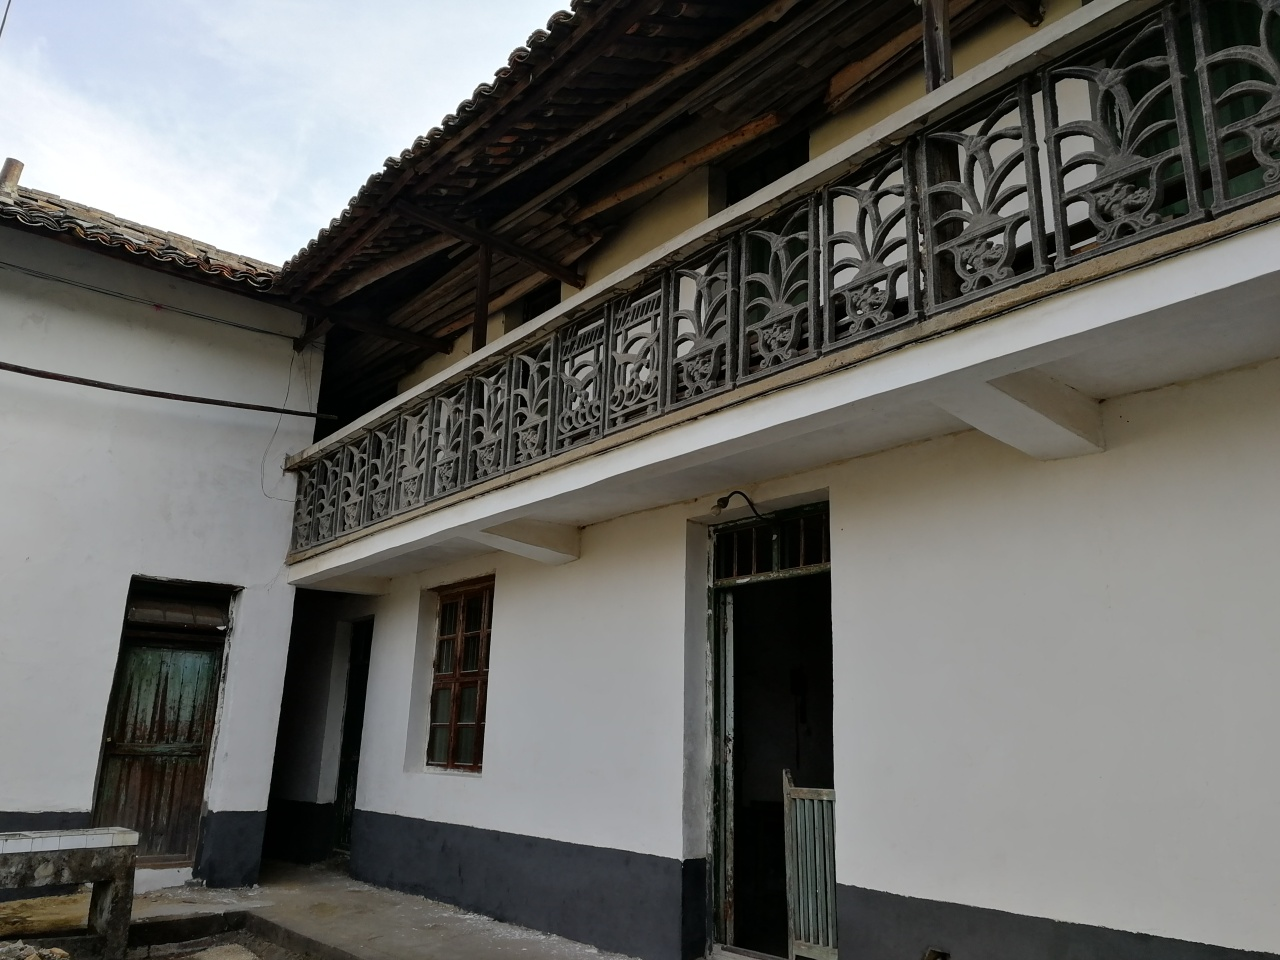Could you describe the architectural style or historical period this building might belong to? The building features characteristics that suggest a colonial-style influence, often seen in buildings from the late 19th to early 20th century. This is indicated by aspects like the symmetrical windows, the railing with ornamental details, and the tiled roof eaves. However, without more context, it's difficult to determine the exact historical period. 